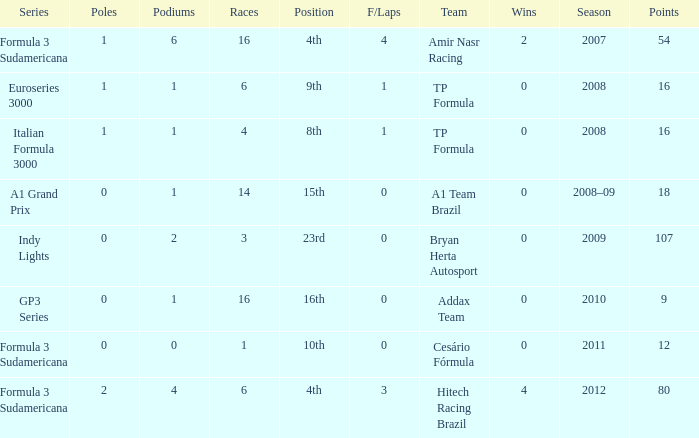How many points did he win in the race with more than 1.0 poles? 80.0. 